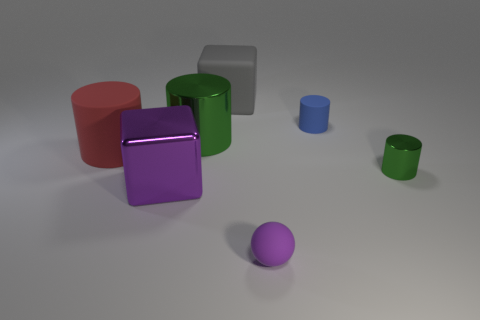Add 2 big green shiny objects. How many objects exist? 9 Subtract all blocks. How many objects are left? 5 Subtract all rubber spheres. Subtract all big red matte objects. How many objects are left? 5 Add 5 large cubes. How many large cubes are left? 7 Add 4 big brown shiny things. How many big brown shiny things exist? 4 Subtract 0 red balls. How many objects are left? 7 